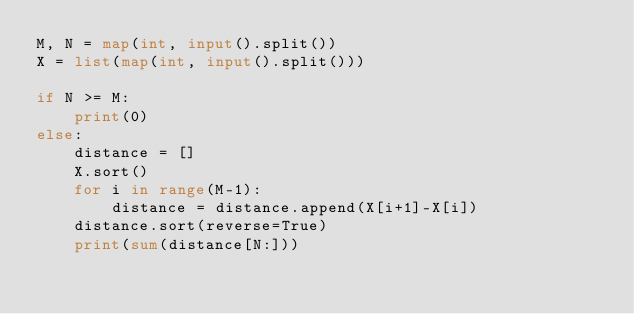<code> <loc_0><loc_0><loc_500><loc_500><_Python_>M, N = map(int, input().split())
X = list(map(int, input().split()))

if N >= M:
    print(0)
else:
    distance = []
    X.sort()
    for i in range(M-1):
        distance = distance.append(X[i+1]-X[i])
    distance.sort(reverse=True)
    print(sum(distance[N:]))</code> 